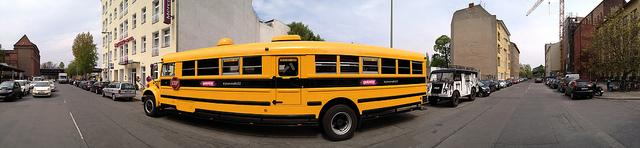What is this yellow bus doing? Please explain your reasoning. turning right. The bus is trying to turn. 